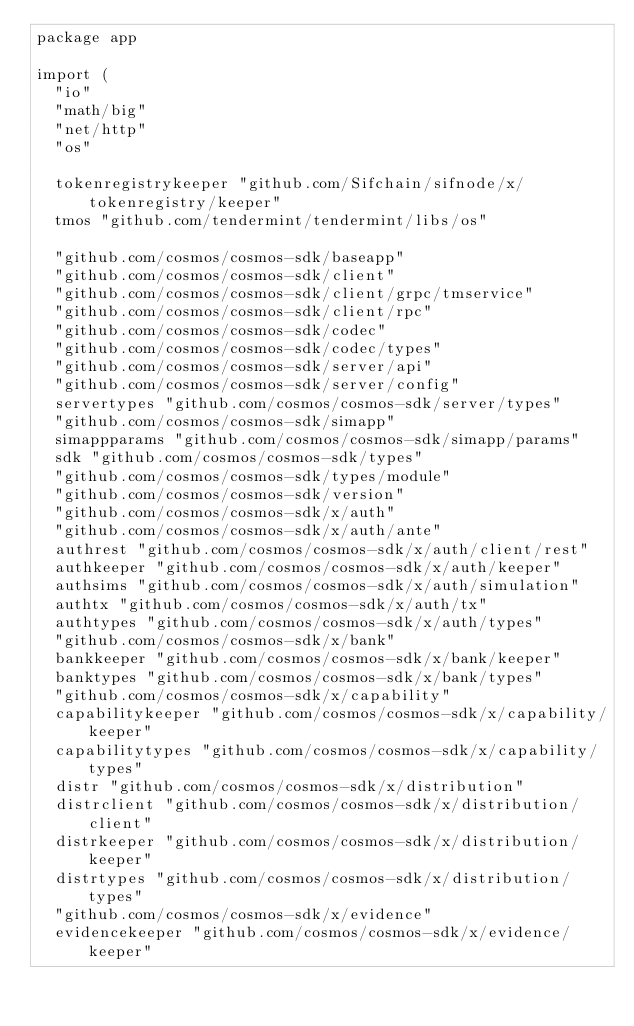Convert code to text. <code><loc_0><loc_0><loc_500><loc_500><_Go_>package app

import (
	"io"
	"math/big"
	"net/http"
	"os"

	tokenregistrykeeper "github.com/Sifchain/sifnode/x/tokenregistry/keeper"
	tmos "github.com/tendermint/tendermint/libs/os"

	"github.com/cosmos/cosmos-sdk/baseapp"
	"github.com/cosmos/cosmos-sdk/client"
	"github.com/cosmos/cosmos-sdk/client/grpc/tmservice"
	"github.com/cosmos/cosmos-sdk/client/rpc"
	"github.com/cosmos/cosmos-sdk/codec"
	"github.com/cosmos/cosmos-sdk/codec/types"
	"github.com/cosmos/cosmos-sdk/server/api"
	"github.com/cosmos/cosmos-sdk/server/config"
	servertypes "github.com/cosmos/cosmos-sdk/server/types"
	"github.com/cosmos/cosmos-sdk/simapp"
	simappparams "github.com/cosmos/cosmos-sdk/simapp/params"
	sdk "github.com/cosmos/cosmos-sdk/types"
	"github.com/cosmos/cosmos-sdk/types/module"
	"github.com/cosmos/cosmos-sdk/version"
	"github.com/cosmos/cosmos-sdk/x/auth"
	"github.com/cosmos/cosmos-sdk/x/auth/ante"
	authrest "github.com/cosmos/cosmos-sdk/x/auth/client/rest"
	authkeeper "github.com/cosmos/cosmos-sdk/x/auth/keeper"
	authsims "github.com/cosmos/cosmos-sdk/x/auth/simulation"
	authtx "github.com/cosmos/cosmos-sdk/x/auth/tx"
	authtypes "github.com/cosmos/cosmos-sdk/x/auth/types"
	"github.com/cosmos/cosmos-sdk/x/bank"
	bankkeeper "github.com/cosmos/cosmos-sdk/x/bank/keeper"
	banktypes "github.com/cosmos/cosmos-sdk/x/bank/types"
	"github.com/cosmos/cosmos-sdk/x/capability"
	capabilitykeeper "github.com/cosmos/cosmos-sdk/x/capability/keeper"
	capabilitytypes "github.com/cosmos/cosmos-sdk/x/capability/types"
	distr "github.com/cosmos/cosmos-sdk/x/distribution"
	distrclient "github.com/cosmos/cosmos-sdk/x/distribution/client"
	distrkeeper "github.com/cosmos/cosmos-sdk/x/distribution/keeper"
	distrtypes "github.com/cosmos/cosmos-sdk/x/distribution/types"
	"github.com/cosmos/cosmos-sdk/x/evidence"
	evidencekeeper "github.com/cosmos/cosmos-sdk/x/evidence/keeper"</code> 